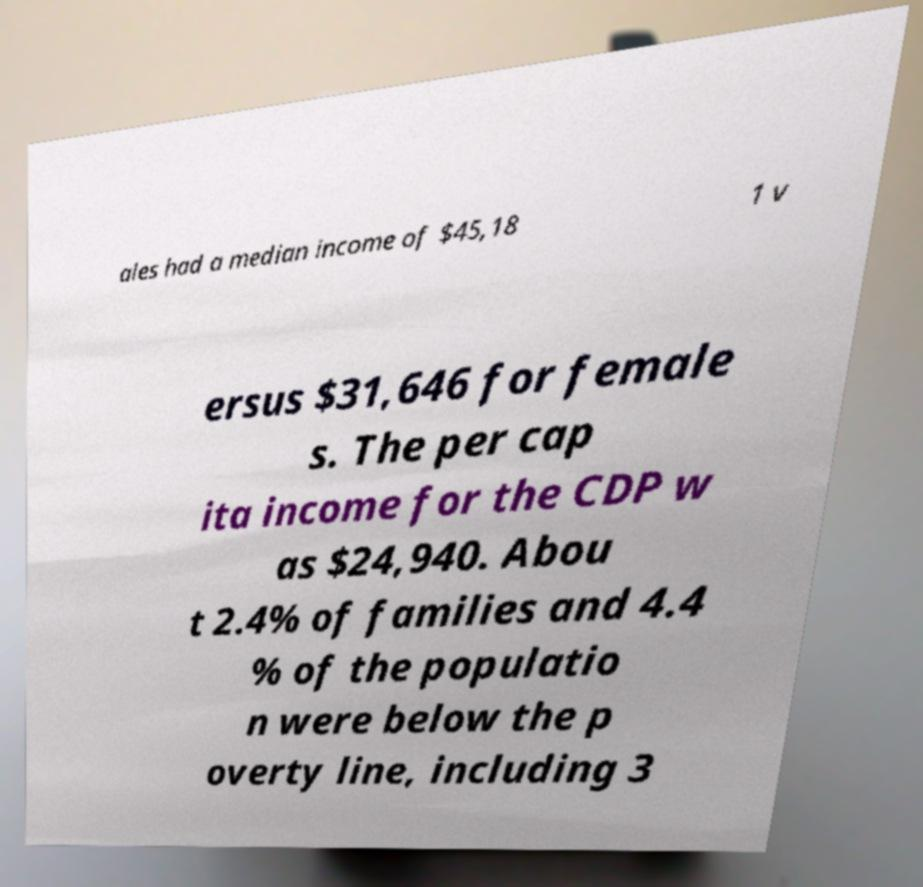Please read and relay the text visible in this image. What does it say? ales had a median income of $45,18 1 v ersus $31,646 for female s. The per cap ita income for the CDP w as $24,940. Abou t 2.4% of families and 4.4 % of the populatio n were below the p overty line, including 3 